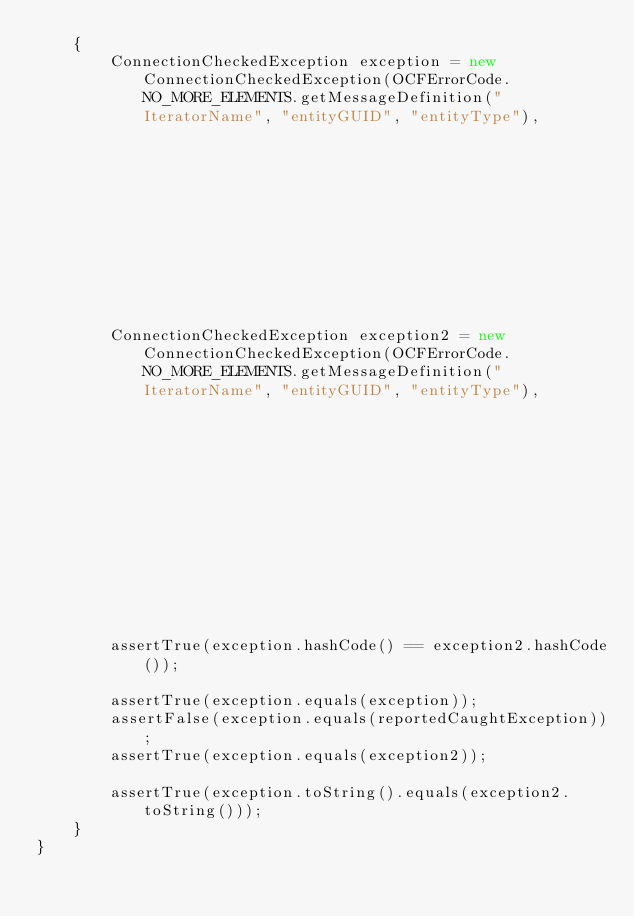Convert code to text. <code><loc_0><loc_0><loc_500><loc_500><_Java_>    {
        ConnectionCheckedException exception = new ConnectionCheckedException(OCFErrorCode.NO_MORE_ELEMENTS.getMessageDefinition("IteratorName", "entityGUID", "entityType"),
                                                                              reportingClassName,
                                                                              reportingActionDescription,
                                                                              reportedCaughtException);

        ConnectionCheckedException exception2 = new ConnectionCheckedException(OCFErrorCode.NO_MORE_ELEMENTS.getMessageDefinition("IteratorName", "entityGUID", "entityType"),
                                                                               reportingClassName,
                                                                               reportingActionDescription,
                                                                               reportedCaughtException);



        assertTrue(exception.hashCode() == exception2.hashCode());

        assertTrue(exception.equals(exception));
        assertFalse(exception.equals(reportedCaughtException));
        assertTrue(exception.equals(exception2));

        assertTrue(exception.toString().equals(exception2.toString()));
    }
}
</code> 